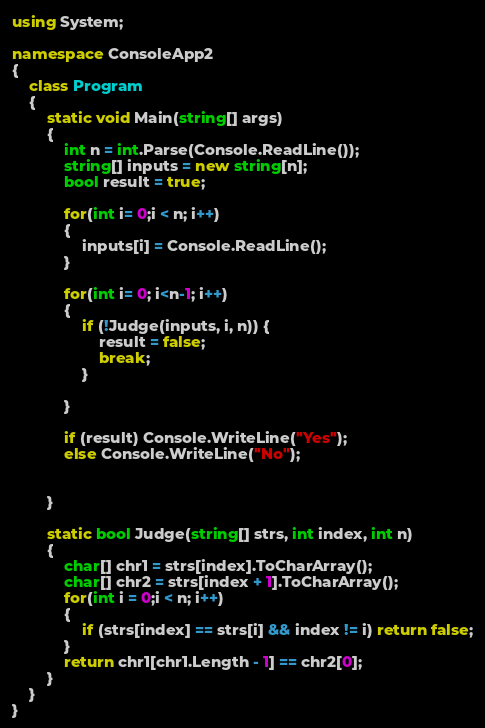Convert code to text. <code><loc_0><loc_0><loc_500><loc_500><_C#_>using System;

namespace ConsoleApp2
{
    class Program
    {
        static void Main(string[] args)
        {
            int n = int.Parse(Console.ReadLine());
            string[] inputs = new string[n];
            bool result = true;

            for(int i= 0;i < n; i++)
            {
                inputs[i] = Console.ReadLine();
            }

            for(int i= 0; i<n-1; i++)
            {
                if (!Judge(inputs, i, n)) {
                    result = false;
                    break;
                }

            }

            if (result) Console.WriteLine("Yes");
            else Console.WriteLine("No");


        }

        static bool Judge(string[] strs, int index, int n)
        {
            char[] chr1 = strs[index].ToCharArray();
            char[] chr2 = strs[index + 1].ToCharArray();
            for(int i = 0;i < n; i++)
            {
                if (strs[index] == strs[i] && index != i) return false;
            }
            return chr1[chr1.Length - 1] == chr2[0];
        }
    }
}
</code> 